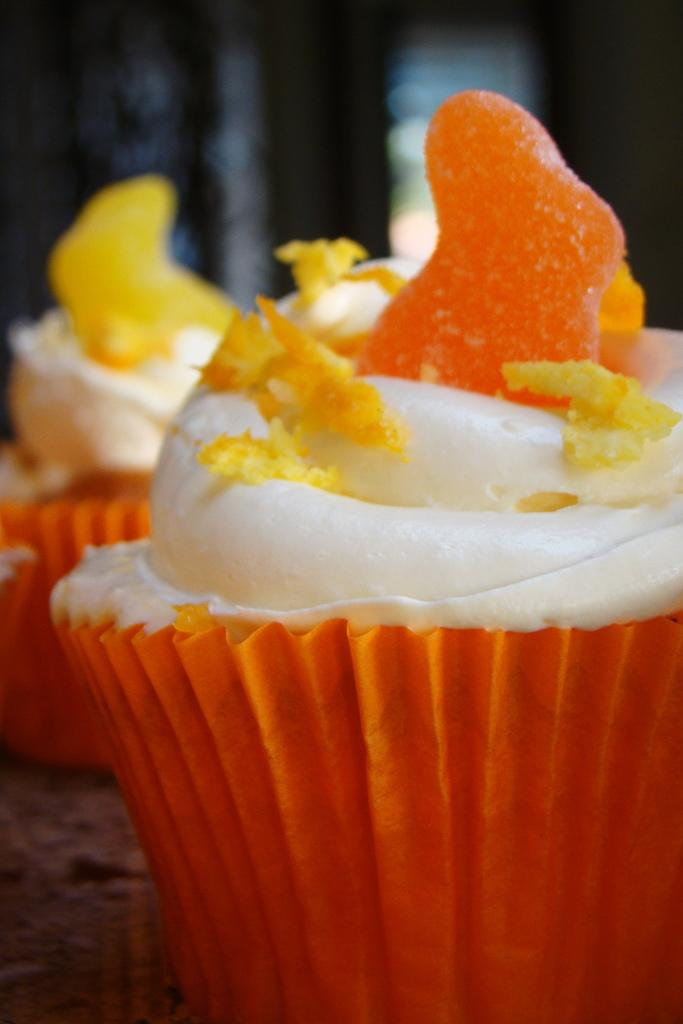What type of dessert can be seen in the picture? There are two cupcakes in the picture. What is inside the cupcakes? The cupcakes have cream filling. What scientific experiment is being conducted with the cupcakes in the picture? There is no scientific experiment being conducted with the cupcakes in the picture; they are simply desserts. Can you see a button on the cupcakes in the picture? There is no button present on the cupcakes in the picture. 